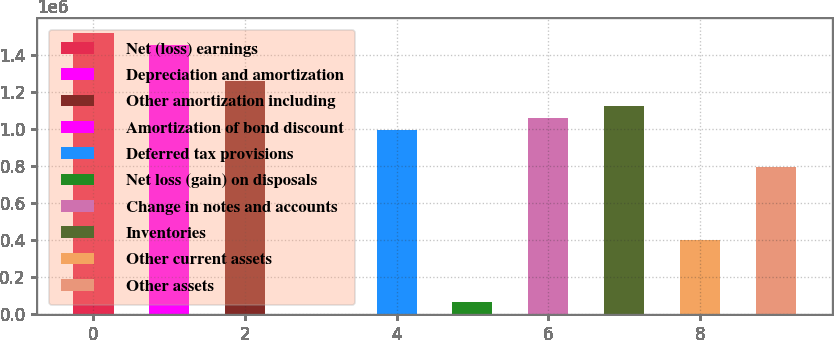<chart> <loc_0><loc_0><loc_500><loc_500><bar_chart><fcel>Net (loss) earnings<fcel>Depreciation and amortization<fcel>Other amortization including<fcel>Amortization of bond discount<fcel>Deferred tax provisions<fcel>Net loss (gain) on disposals<fcel>Change in notes and accounts<fcel>Inventories<fcel>Other current assets<fcel>Other assets<nl><fcel>1.52e+06<fcel>1.45392e+06<fcel>1.2557e+06<fcel>318<fcel>991413<fcel>66391<fcel>1.05749e+06<fcel>1.12356e+06<fcel>396756<fcel>793194<nl></chart> 